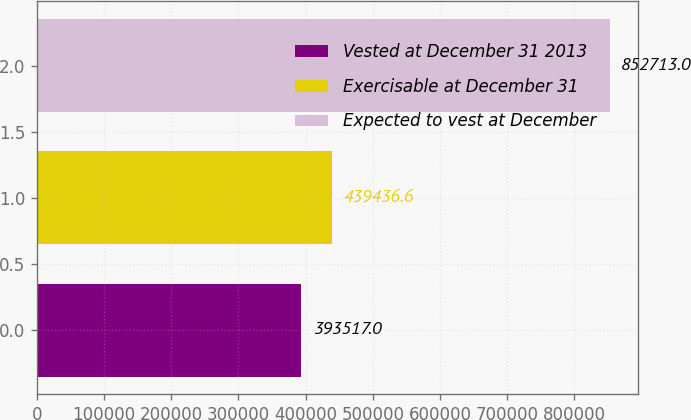Convert chart to OTSL. <chart><loc_0><loc_0><loc_500><loc_500><bar_chart><fcel>Vested at December 31 2013<fcel>Exercisable at December 31<fcel>Expected to vest at December<nl><fcel>393517<fcel>439437<fcel>852713<nl></chart> 